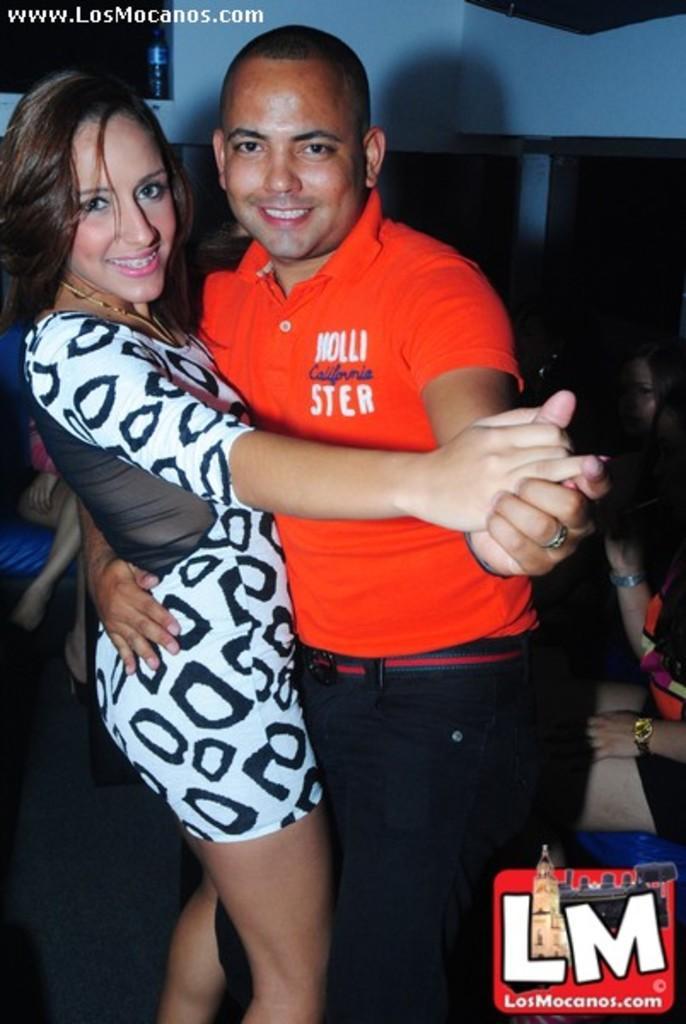How would you summarize this image in a sentence or two? In this image I can see two persons standing. The person at right wearing orange color shirt, black pant and the person at left wearing white and black color dress, at the back I can see wall in white color. 